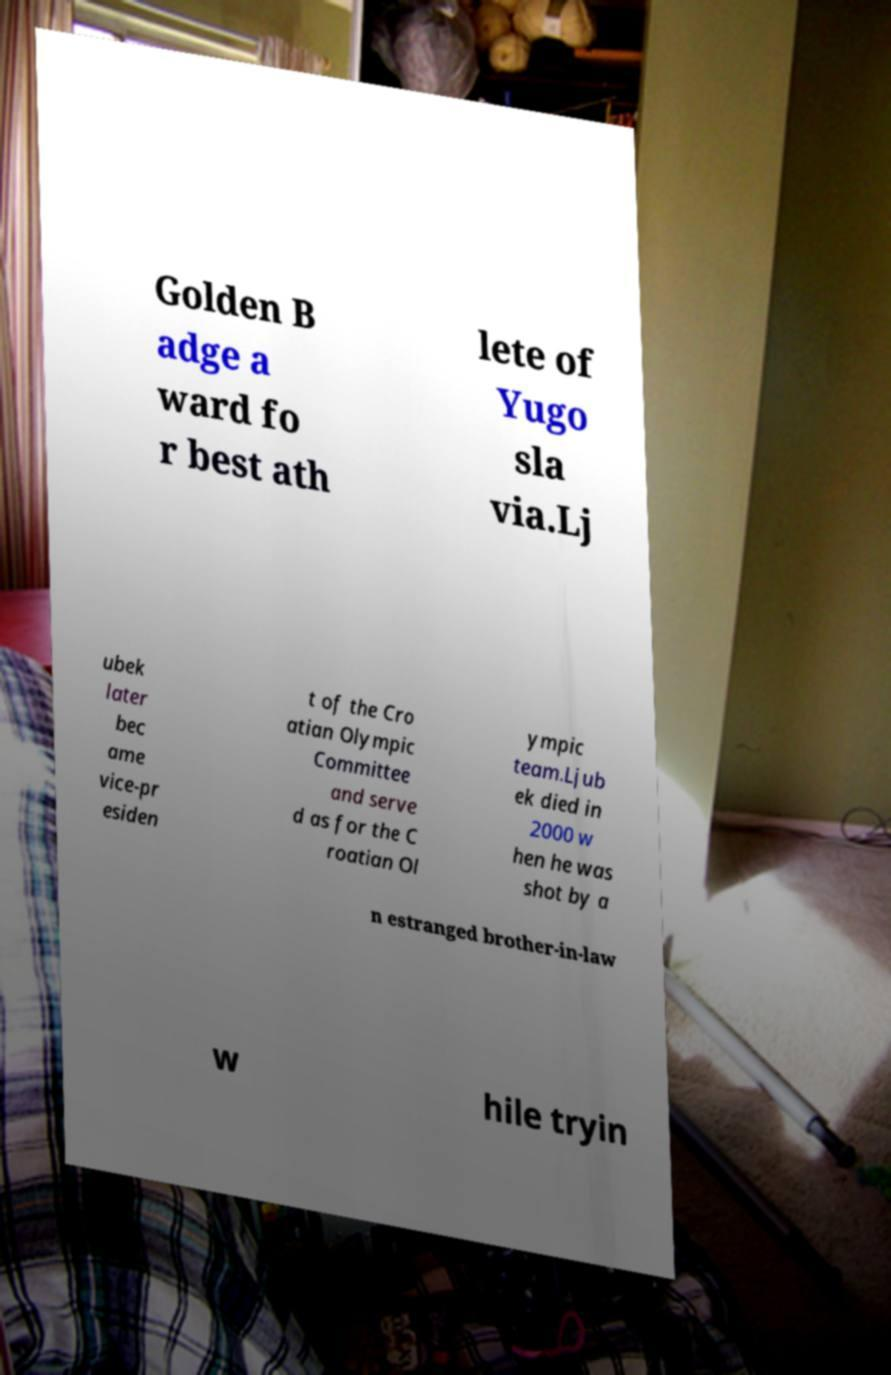What messages or text are displayed in this image? I need them in a readable, typed format. Golden B adge a ward fo r best ath lete of Yugo sla via.Lj ubek later bec ame vice-pr esiden t of the Cro atian Olympic Committee and serve d as for the C roatian Ol ympic team.Ljub ek died in 2000 w hen he was shot by a n estranged brother-in-law w hile tryin 